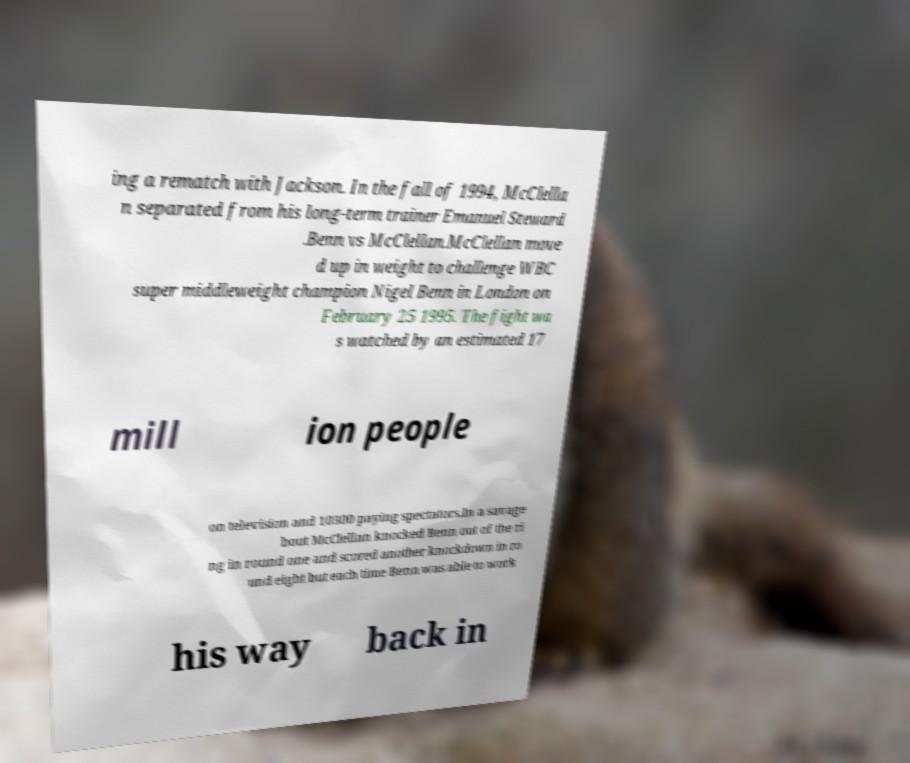Could you extract and type out the text from this image? ing a rematch with Jackson. In the fall of 1994, McClella n separated from his long-term trainer Emanuel Steward .Benn vs McClellan.McClellan move d up in weight to challenge WBC super middleweight champion Nigel Benn in London on February 25 1995. The fight wa s watched by an estimated 17 mill ion people on television and 10300 paying spectators.In a savage bout McClellan knocked Benn out of the ri ng in round one and scored another knockdown in ro und eight but each time Benn was able to work his way back in 